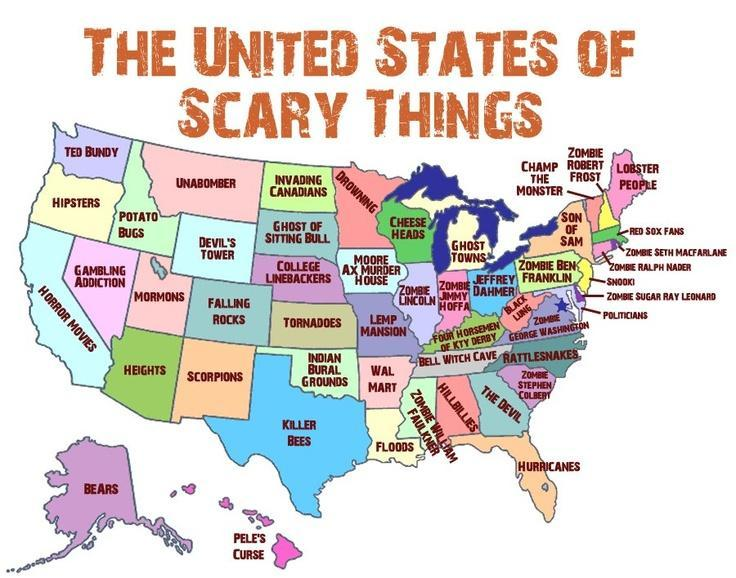Which island lies to the south of Killer Bees ?
Answer the question with a short phrase. PELE'S CURSE Which region lies to the north of Wal- Mart ? LEMP MANSION Which regions lies to the south of Heights ? BEARS 